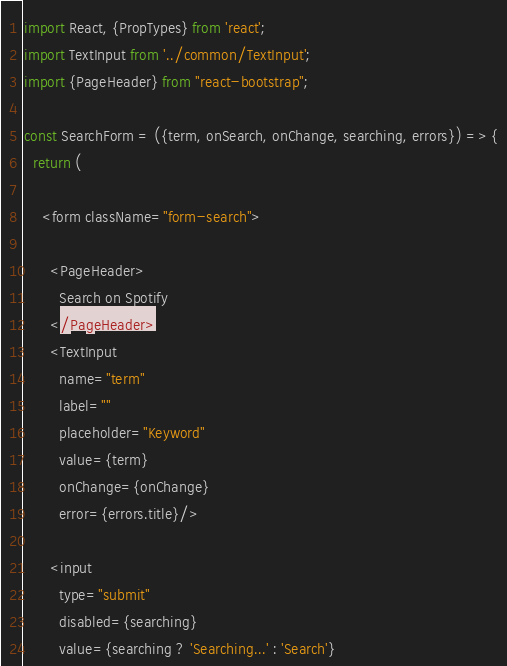Convert code to text. <code><loc_0><loc_0><loc_500><loc_500><_JavaScript_>import React, {PropTypes} from 'react';
import TextInput from '../common/TextInput';
import {PageHeader} from "react-bootstrap";

const SearchForm = ({term, onSearch, onChange, searching, errors}) => {
  return (

    <form className="form-search">

      <PageHeader>
        Search on Spotify
      </PageHeader>
      <TextInput
        name="term"
        label=""
        placeholder="Keyword"
        value={term}
        onChange={onChange}
        error={errors.title}/>

      <input
        type="submit"
        disabled={searching}
        value={searching ? 'Searching...' : 'Search'}</code> 